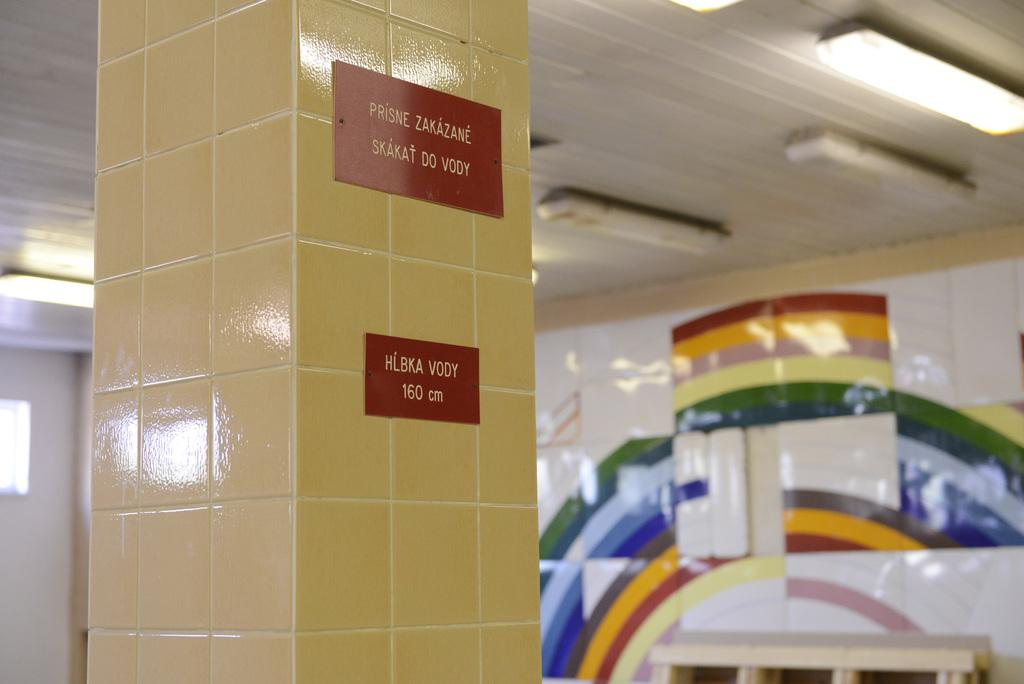What is located in the foreground of the image? There is a pillar in the foreground of the image. What is attached to the pillar? Name plates are present on the pillar. What can be seen in the background of the image? There are lights, a bench, and a wall in the background of the image. What type of instrument can be seen being played through the window in the image? There is no window or instrument present in the image. 